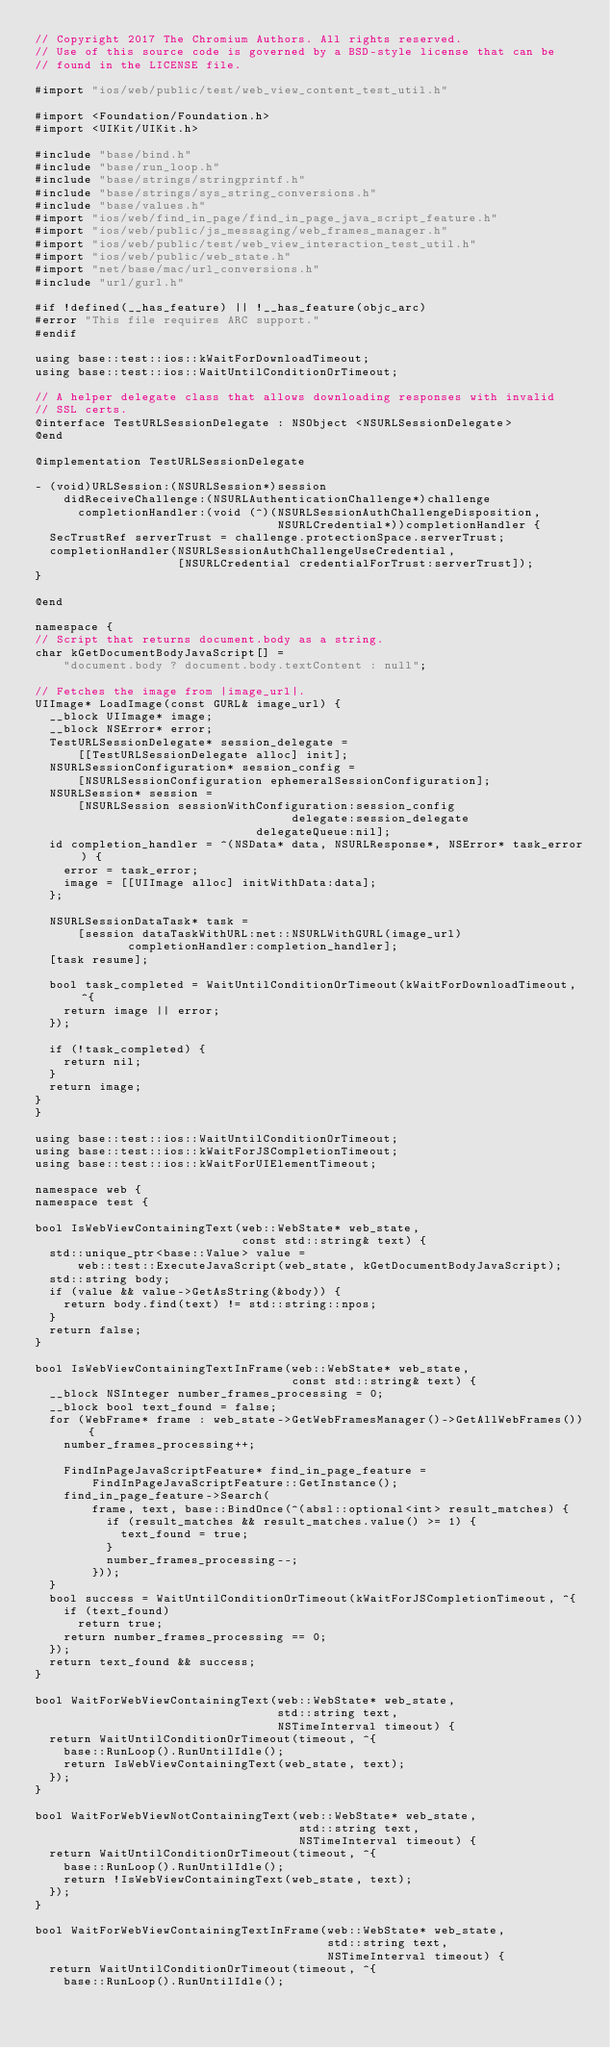<code> <loc_0><loc_0><loc_500><loc_500><_ObjectiveC_>// Copyright 2017 The Chromium Authors. All rights reserved.
// Use of this source code is governed by a BSD-style license that can be
// found in the LICENSE file.

#import "ios/web/public/test/web_view_content_test_util.h"

#import <Foundation/Foundation.h>
#import <UIKit/UIKit.h>

#include "base/bind.h"
#include "base/run_loop.h"
#include "base/strings/stringprintf.h"
#include "base/strings/sys_string_conversions.h"
#include "base/values.h"
#import "ios/web/find_in_page/find_in_page_java_script_feature.h"
#import "ios/web/public/js_messaging/web_frames_manager.h"
#import "ios/web/public/test/web_view_interaction_test_util.h"
#import "ios/web/public/web_state.h"
#import "net/base/mac/url_conversions.h"
#include "url/gurl.h"

#if !defined(__has_feature) || !__has_feature(objc_arc)
#error "This file requires ARC support."
#endif

using base::test::ios::kWaitForDownloadTimeout;
using base::test::ios::WaitUntilConditionOrTimeout;

// A helper delegate class that allows downloading responses with invalid
// SSL certs.
@interface TestURLSessionDelegate : NSObject <NSURLSessionDelegate>
@end

@implementation TestURLSessionDelegate

- (void)URLSession:(NSURLSession*)session
    didReceiveChallenge:(NSURLAuthenticationChallenge*)challenge
      completionHandler:(void (^)(NSURLSessionAuthChallengeDisposition,
                                  NSURLCredential*))completionHandler {
  SecTrustRef serverTrust = challenge.protectionSpace.serverTrust;
  completionHandler(NSURLSessionAuthChallengeUseCredential,
                    [NSURLCredential credentialForTrust:serverTrust]);
}

@end

namespace {
// Script that returns document.body as a string.
char kGetDocumentBodyJavaScript[] =
    "document.body ? document.body.textContent : null";

// Fetches the image from |image_url|.
UIImage* LoadImage(const GURL& image_url) {
  __block UIImage* image;
  __block NSError* error;
  TestURLSessionDelegate* session_delegate =
      [[TestURLSessionDelegate alloc] init];
  NSURLSessionConfiguration* session_config =
      [NSURLSessionConfiguration ephemeralSessionConfiguration];
  NSURLSession* session =
      [NSURLSession sessionWithConfiguration:session_config
                                    delegate:session_delegate
                               delegateQueue:nil];
  id completion_handler = ^(NSData* data, NSURLResponse*, NSError* task_error) {
    error = task_error;
    image = [[UIImage alloc] initWithData:data];
  };

  NSURLSessionDataTask* task =
      [session dataTaskWithURL:net::NSURLWithGURL(image_url)
             completionHandler:completion_handler];
  [task resume];

  bool task_completed = WaitUntilConditionOrTimeout(kWaitForDownloadTimeout, ^{
    return image || error;
  });

  if (!task_completed) {
    return nil;
  }
  return image;
}
}

using base::test::ios::WaitUntilConditionOrTimeout;
using base::test::ios::kWaitForJSCompletionTimeout;
using base::test::ios::kWaitForUIElementTimeout;

namespace web {
namespace test {

bool IsWebViewContainingText(web::WebState* web_state,
                             const std::string& text) {
  std::unique_ptr<base::Value> value =
      web::test::ExecuteJavaScript(web_state, kGetDocumentBodyJavaScript);
  std::string body;
  if (value && value->GetAsString(&body)) {
    return body.find(text) != std::string::npos;
  }
  return false;
}

bool IsWebViewContainingTextInFrame(web::WebState* web_state,
                                    const std::string& text) {
  __block NSInteger number_frames_processing = 0;
  __block bool text_found = false;
  for (WebFrame* frame : web_state->GetWebFramesManager()->GetAllWebFrames()) {
    number_frames_processing++;

    FindInPageJavaScriptFeature* find_in_page_feature =
        FindInPageJavaScriptFeature::GetInstance();
    find_in_page_feature->Search(
        frame, text, base::BindOnce(^(absl::optional<int> result_matches) {
          if (result_matches && result_matches.value() >= 1) {
            text_found = true;
          }
          number_frames_processing--;
        }));
  }
  bool success = WaitUntilConditionOrTimeout(kWaitForJSCompletionTimeout, ^{
    if (text_found)
      return true;
    return number_frames_processing == 0;
  });
  return text_found && success;
}

bool WaitForWebViewContainingText(web::WebState* web_state,
                                  std::string text,
                                  NSTimeInterval timeout) {
  return WaitUntilConditionOrTimeout(timeout, ^{
    base::RunLoop().RunUntilIdle();
    return IsWebViewContainingText(web_state, text);
  });
}

bool WaitForWebViewNotContainingText(web::WebState* web_state,
                                     std::string text,
                                     NSTimeInterval timeout) {
  return WaitUntilConditionOrTimeout(timeout, ^{
    base::RunLoop().RunUntilIdle();
    return !IsWebViewContainingText(web_state, text);
  });
}

bool WaitForWebViewContainingTextInFrame(web::WebState* web_state,
                                         std::string text,
                                         NSTimeInterval timeout) {
  return WaitUntilConditionOrTimeout(timeout, ^{
    base::RunLoop().RunUntilIdle();</code> 